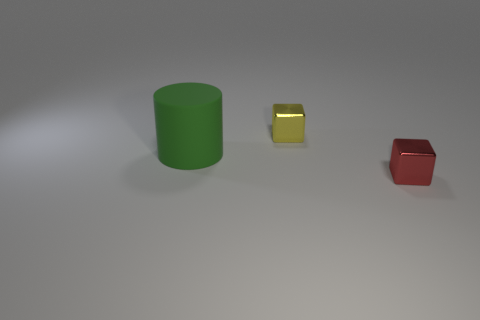Is there anything else that has the same material as the big green object?
Offer a very short reply. No. Is there any other thing that has the same shape as the big thing?
Keep it short and to the point. No. What number of spheres are yellow metallic things or purple matte things?
Provide a short and direct response. 0. What is the color of the tiny object that is in front of the green cylinder?
Offer a very short reply. Red. There is a red object that is the same size as the yellow object; what shape is it?
Keep it short and to the point. Cube. There is a big green object; what number of yellow objects are in front of it?
Ensure brevity in your answer.  0. What number of things are either small purple metallic balls or red metallic things?
Ensure brevity in your answer.  1. What is the shape of the object that is both behind the tiny red metal thing and in front of the yellow thing?
Keep it short and to the point. Cylinder. How many big matte cylinders are there?
Keep it short and to the point. 1. There is a cube that is the same material as the yellow object; what color is it?
Ensure brevity in your answer.  Red. 